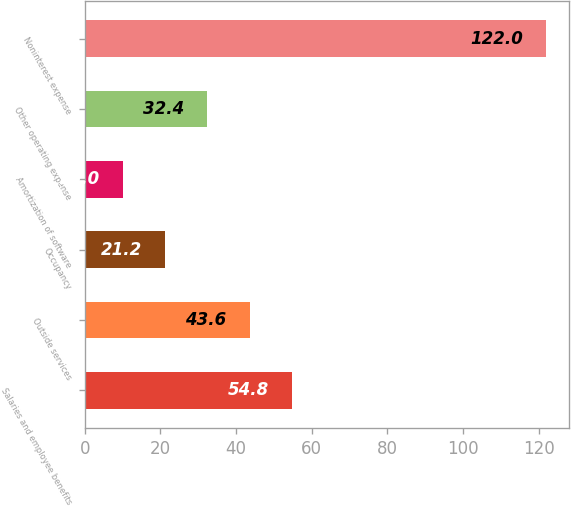<chart> <loc_0><loc_0><loc_500><loc_500><bar_chart><fcel>Salaries and employee benefits<fcel>Outside services<fcel>Occupancy<fcel>Amortization of software<fcel>Other operating expense<fcel>Noninterest expense<nl><fcel>54.8<fcel>43.6<fcel>21.2<fcel>10<fcel>32.4<fcel>122<nl></chart> 